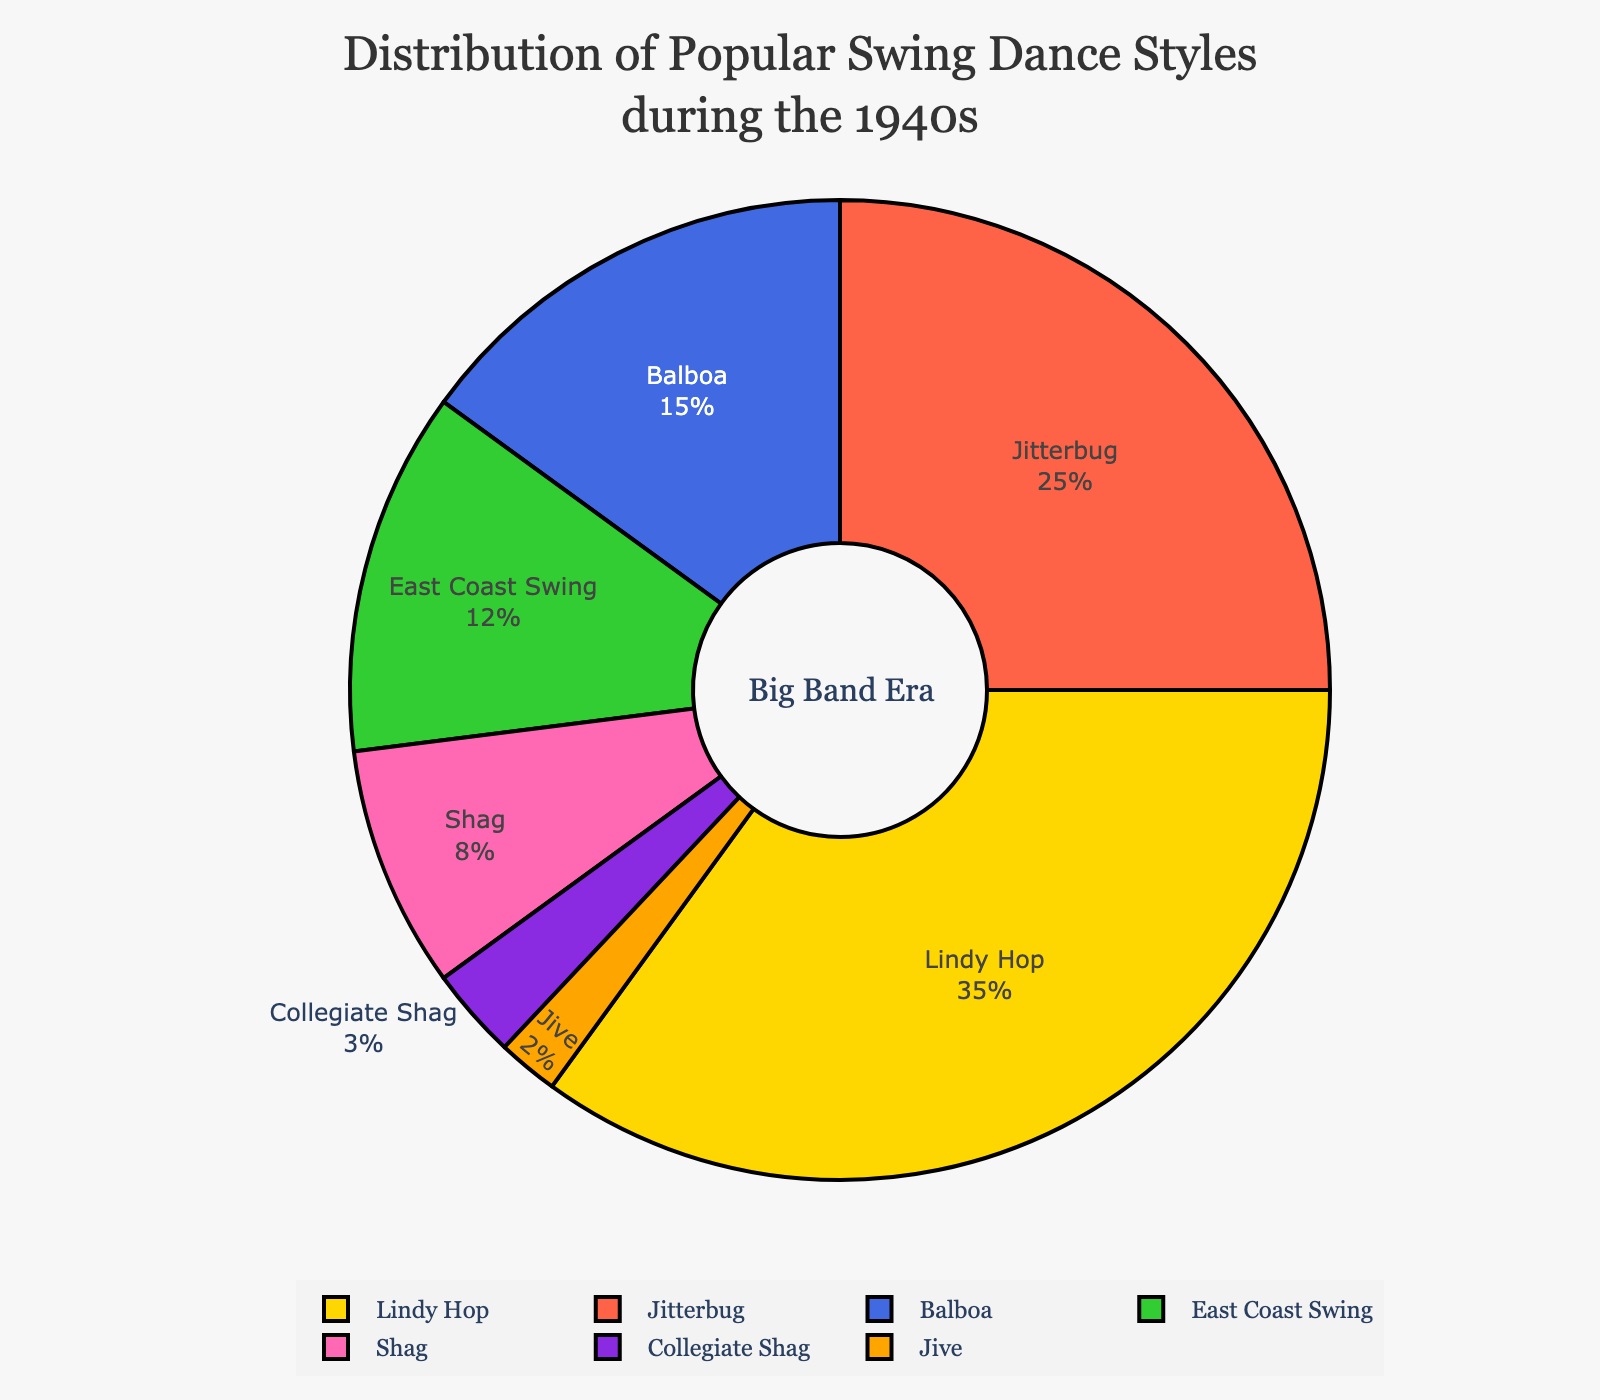What percentage of the pie chart represents Lindy Hop? By reading the pie chart, Lindy Hop occupies 35%.
Answer: 35% Which two dance styles combined have the highest percentage? Lindy Hop has 35% and Jitterbug has 25%. Adding them together gives 60%, which is higher than any other combination.
Answer: Lindy Hop and Jitterbug How many dance styles occupy a greater percentage than East Coast Swing? East Coast Swing occupies 12%. Lindy Hop (35%), Jitterbug (25%), and Balboa (15%) all have a greater percentage than East Coast Swing.
Answer: 3 What is the percentage difference between Lindy Hop and Shag? Lindy Hop has 35% and Shag has 8%. The difference is calculated as 35 - 8 = 27%.
Answer: 27% Which dance style occupies the smallest portion of the pie chart? By looking at the chart, Jive occupies the smallest portion with 2%.
Answer: Jive If the percentages for Lindy Hop and Jitterbug were combined, what fraction of the pie chart would it represent in decimal form? Lindy Hop is 35% and Jitterbug is 25%. Combined, they are 60%, which in decimal form is 0.60.
Answer: 0.60 Compare the combined percentage of Balboa and East Coast Swing with that of Lindy Hop. Which is greater? The combined percentage of Balboa (15%) and East Coast Swing (12%) is 27%. Lindy Hop alone is 35%. Therefore, Lindy Hop's percentage is greater.
Answer: Lindy Hop What is the visual difference in size between the largest and smallest dance styles? The largest segment, Lindy Hop, is 35%. The smallest segment, Jive, is 2%. The difference in size is 35% - 2% = 33%.
Answer: 33% Identify the dance style represented by the pink color in the pie chart. In the legend of the pie chart, the pink color corresponds to Shag, which has an 8% share.
Answer: Shag 